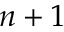Convert formula to latex. <formula><loc_0><loc_0><loc_500><loc_500>n + 1</formula> 